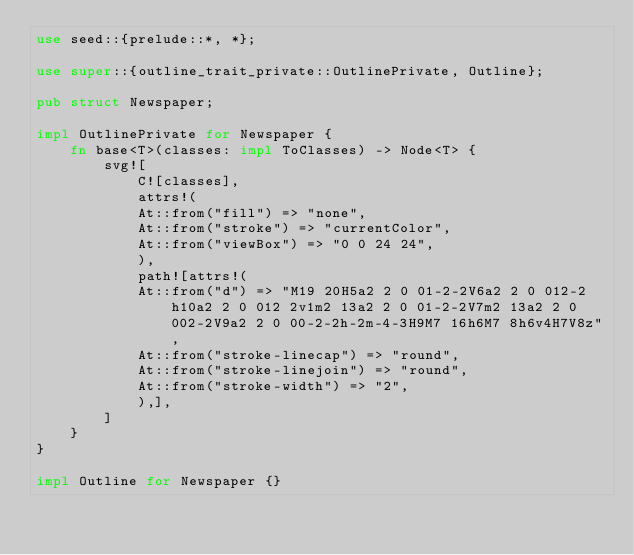<code> <loc_0><loc_0><loc_500><loc_500><_Rust_>use seed::{prelude::*, *};

use super::{outline_trait_private::OutlinePrivate, Outline};

pub struct Newspaper;

impl OutlinePrivate for Newspaper {
    fn base<T>(classes: impl ToClasses) -> Node<T> {
        svg![
            C![classes],
            attrs!(
            At::from("fill") => "none",
            At::from("stroke") => "currentColor",
            At::from("viewBox") => "0 0 24 24",
            ),
            path![attrs!(
            At::from("d") => "M19 20H5a2 2 0 01-2-2V6a2 2 0 012-2h10a2 2 0 012 2v1m2 13a2 2 0 01-2-2V7m2 13a2 2 0 002-2V9a2 2 0 00-2-2h-2m-4-3H9M7 16h6M7 8h6v4H7V8z",
            At::from("stroke-linecap") => "round",
            At::from("stroke-linejoin") => "round",
            At::from("stroke-width") => "2",
            ),],
        ]
    }
}

impl Outline for Newspaper {}
</code> 